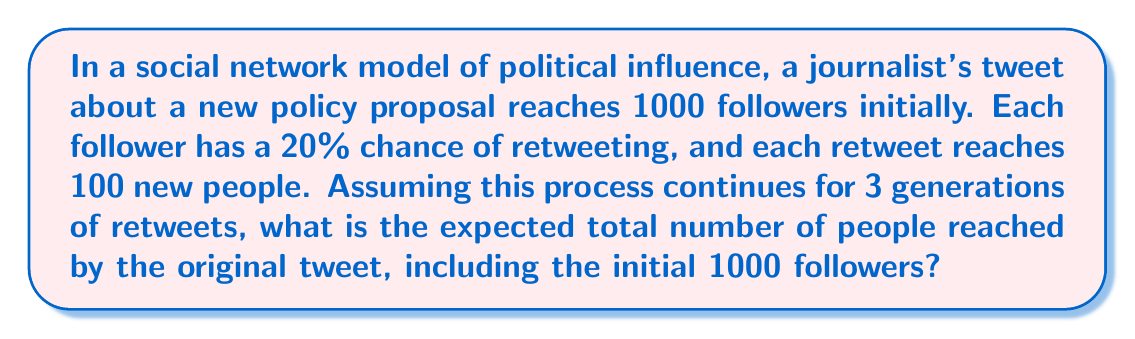Solve this math problem. Let's break this down step-by-step:

1) Initial reach: 1000 people

2) First generation of retweets:
   - Number of people retweeting: $1000 \times 0.20 = 200$
   - New people reached: $200 \times 100 = 20,000$

3) Second generation of retweets:
   - Number of people from first generation who might retweet: 20,000
   - Number of people retweeting: $20,000 \times 0.20 = 4,000$
   - New people reached: $4,000 \times 100 = 400,000$

4) Third generation of retweets:
   - Number of people from second generation who might retweet: 400,000
   - Number of people retweeting: $400,000 \times 0.20 = 80,000$
   - New people reached: $80,000 \times 100 = 8,000,000$

5) Total reach:
   $$\text{Total} = \text{Initial} + \text{1st Gen} + \text{2nd Gen} + \text{3rd Gen}$$
   $$\text{Total} = 1,000 + 20,000 + 400,000 + 8,000,000$$

6) Calculate the sum:
   $$\text{Total} = 8,421,000$$

The expected total number of people reached after 3 generations of retweets is 8,421,000.
Answer: 8,421,000 people 